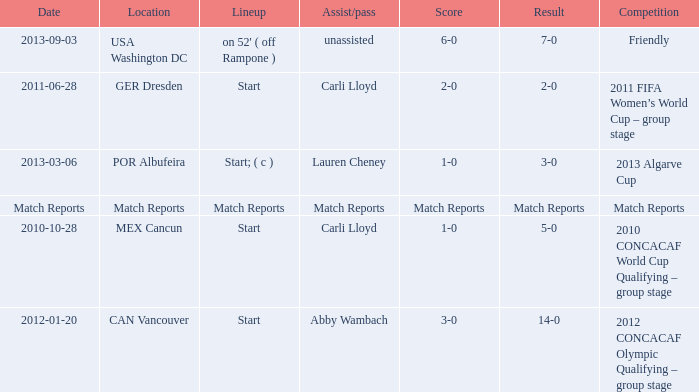Which score has a competition of match reports? Match Reports. 